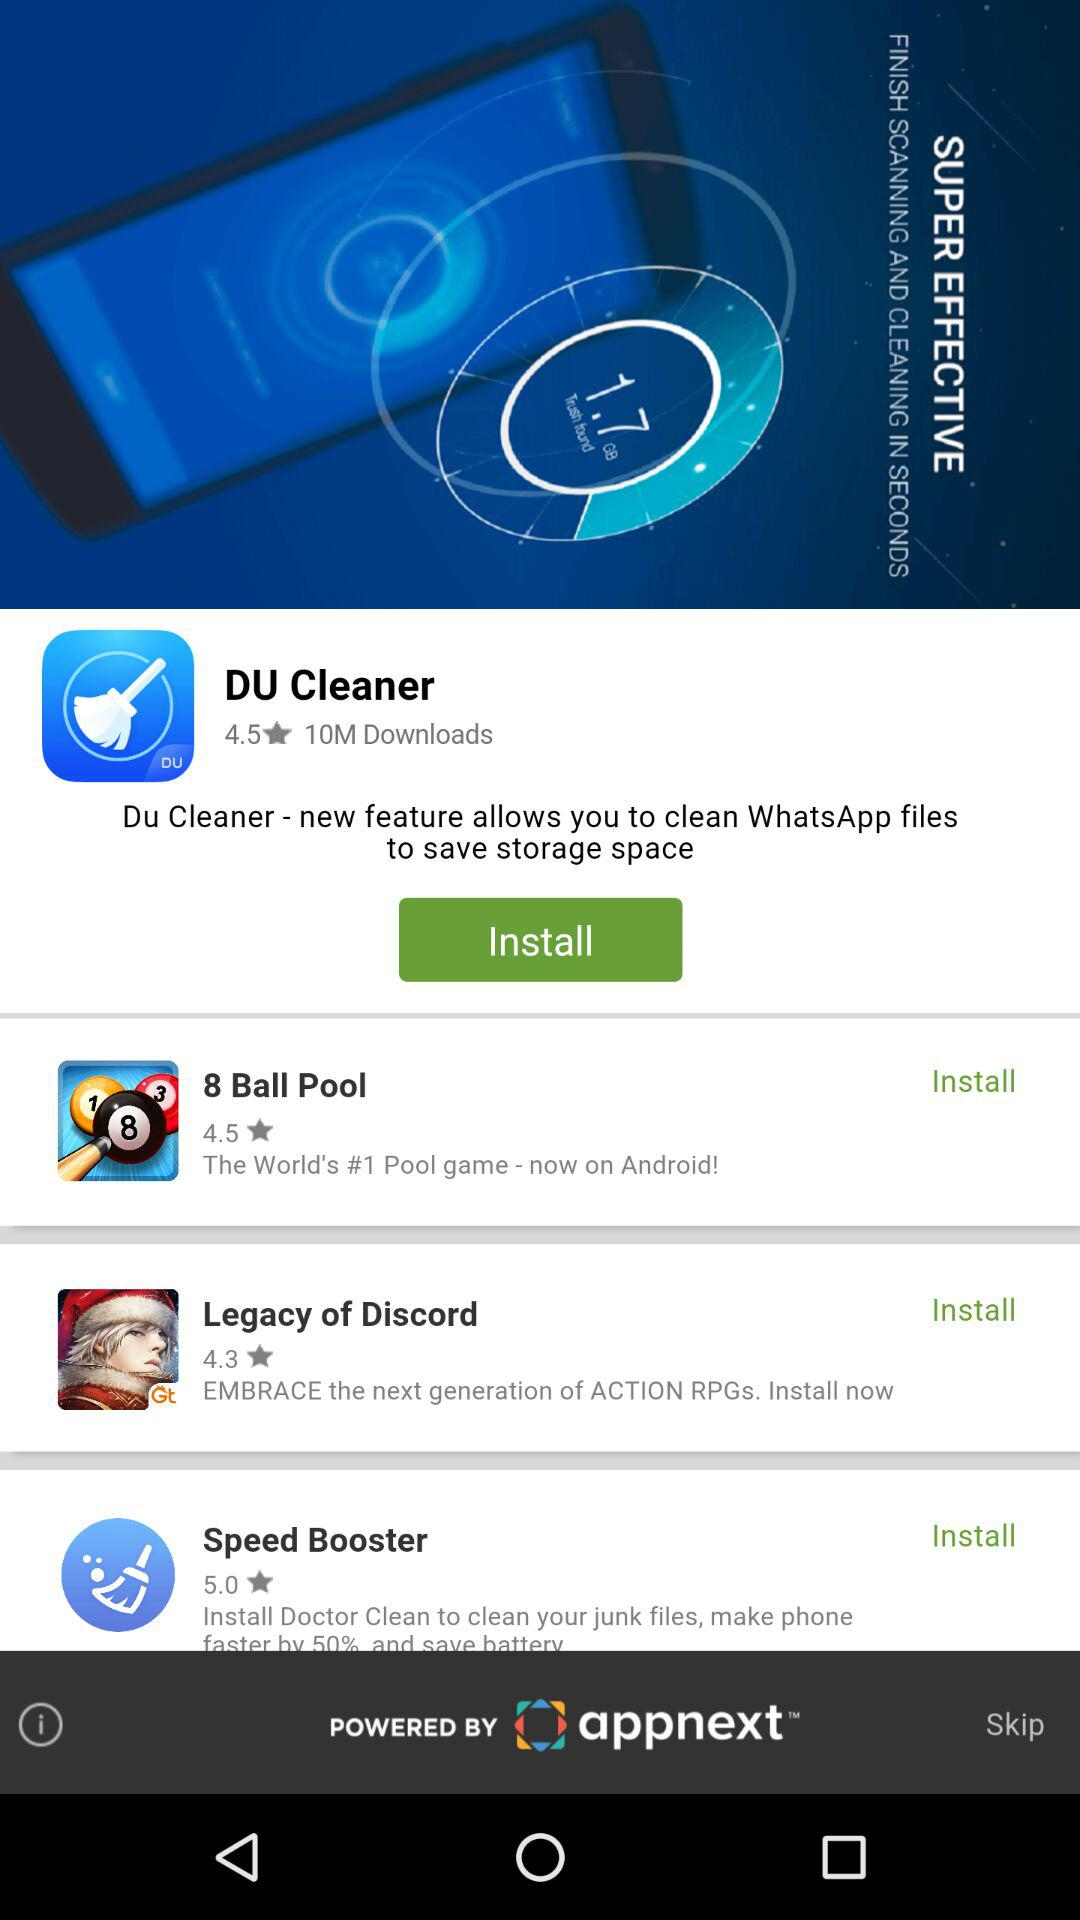What is the rating of 8 ball pool? The rating of the 8 ball pool is 4.5 stars. 